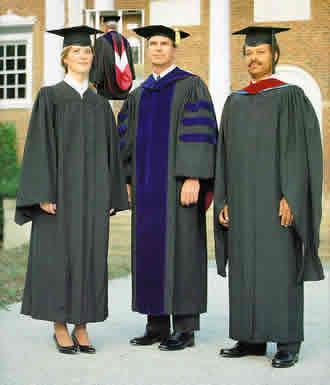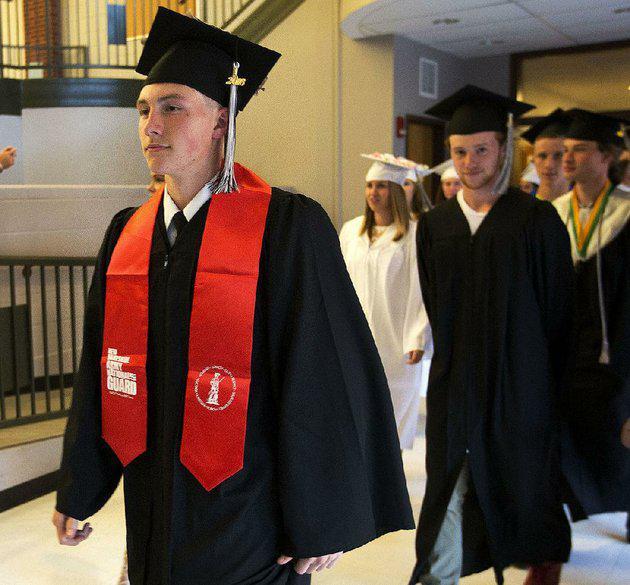The first image is the image on the left, the second image is the image on the right. Analyze the images presented: Is the assertion "There are at least two white shirt fronts visible in the image on the right" valid? Answer yes or no. No. 